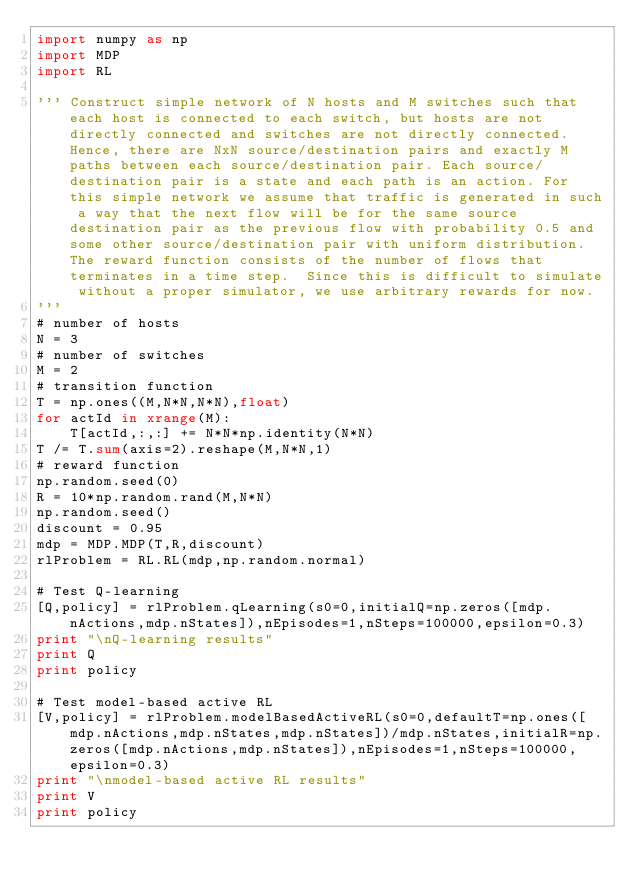Convert code to text. <code><loc_0><loc_0><loc_500><loc_500><_Python_>import numpy as np
import MDP
import RL

''' Construct simple network of N hosts and M switches such that each host is connected to each switch, but hosts are not directly connected and switches are not directly connected. Hence, there are NxN source/destination pairs and exactly M paths between each source/destination pair. Each source/destination pair is a state and each path is an action. For this simple network we assume that traffic is generated in such a way that the next flow will be for the same source destination pair as the previous flow with probability 0.5 and some other source/destination pair with uniform distribution. The reward function consists of the number of flows that terminates in a time step.  Since this is difficult to simulate without a proper simulator, we use arbitrary rewards for now. 
'''
# number of hosts
N = 3
# number of switches
M = 2
# transition function
T = np.ones((M,N*N,N*N),float)
for actId in xrange(M):
    T[actId,:,:] += N*N*np.identity(N*N)
T /= T.sum(axis=2).reshape(M,N*N,1)
# reward function
np.random.seed(0)
R = 10*np.random.rand(M,N*N)
np.random.seed()
discount = 0.95        
mdp = MDP.MDP(T,R,discount)
rlProblem = RL.RL(mdp,np.random.normal)

# Test Q-learning 
[Q,policy] = rlProblem.qLearning(s0=0,initialQ=np.zeros([mdp.nActions,mdp.nStates]),nEpisodes=1,nSteps=100000,epsilon=0.3)
print "\nQ-learning results"
print Q
print policy

# Test model-based active RL
[V,policy] = rlProblem.modelBasedActiveRL(s0=0,defaultT=np.ones([mdp.nActions,mdp.nStates,mdp.nStates])/mdp.nStates,initialR=np.zeros([mdp.nActions,mdp.nStates]),nEpisodes=1,nSteps=100000,epsilon=0.3)
print "\nmodel-based active RL results"
print V
print policy

</code> 